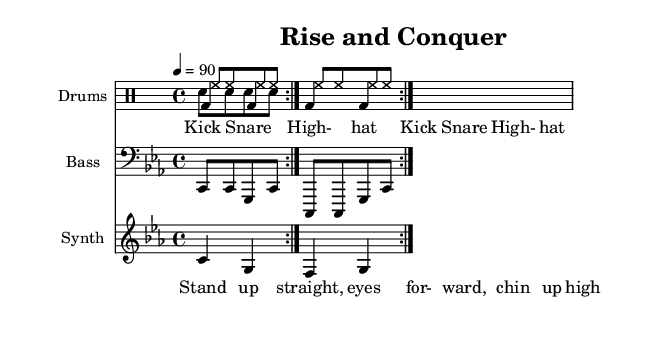What is the key signature of this music? The key signature is indicated at the beginning and shows a flat on the B line, making it C minor.
Answer: C minor What is the time signature of the piece? The time signature at the beginning shows 4/4, meaning there are four beats in each measure and the quarter note gets the beat.
Answer: 4/4 What is the tempo marking shown in the sheet? The tempo marking indicates that the piece should be played at a tempo of 90 beats per minute, which is relatively moderate and allows for clear articulation of the lyrics.
Answer: 90 How many measures are repeated in the drum part? The drum part has a repeat sign around 2 measures indicated, meaning the first 2 measures should be played twice.
Answer: 2 What instrument plays the bass line? The bass part is labeled with a bass clef, indicating it is played on a bass instrument or synthesizer for the low frequencies that drive the rhythm of the rap.
Answer: Bass What type of rhythmic pattern is predominantly used in the drum part? The drum part features a consistent pattern with kick and snare alternating in a steady rhythm, which is typical for creating a hard-hitting beat in rap music.
Answer: Alternating kick and snare Which lyrics are repeated in the piece? The lyrics at the bottom reflect a call to action, with "Stand up straight, eyes forward, chin up high" affirming a theme of perseverance and leadership, implying they are central to the message.
Answer: Stand up straight, eyes forward, chin up high 